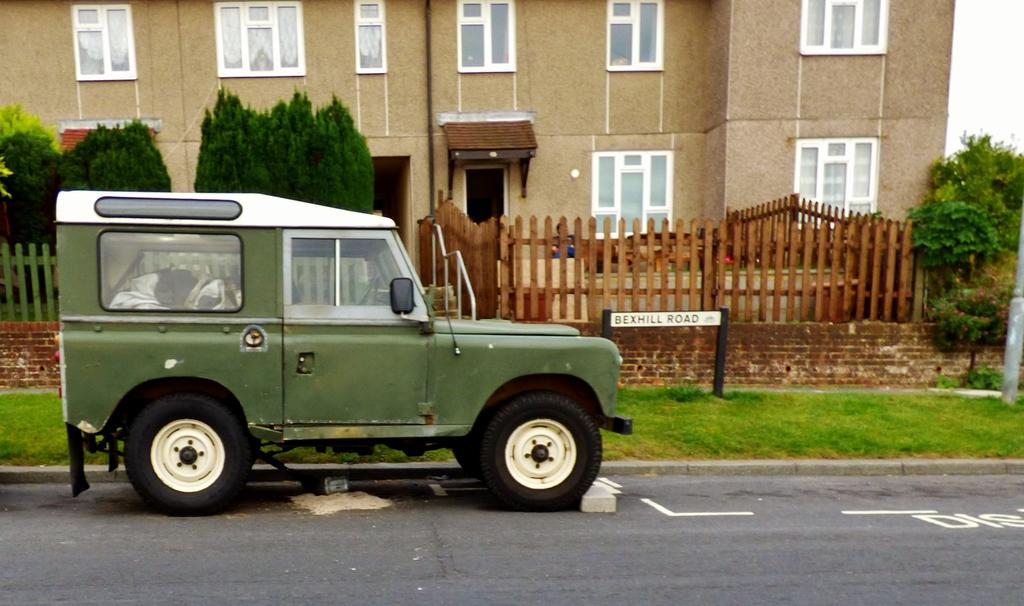What is on the road in the image? There is a vehicle on the road in the image. What can be seen behind the vehicle? There is fencing, trees, and a building at the back. What type of vegetation is visible in the image? Trees are visible in the image. What structure is located at the back? There is a building at the back. What type of glove is being used to join the fencing in the image? There is no glove or activity of joining fencing present in the image. 